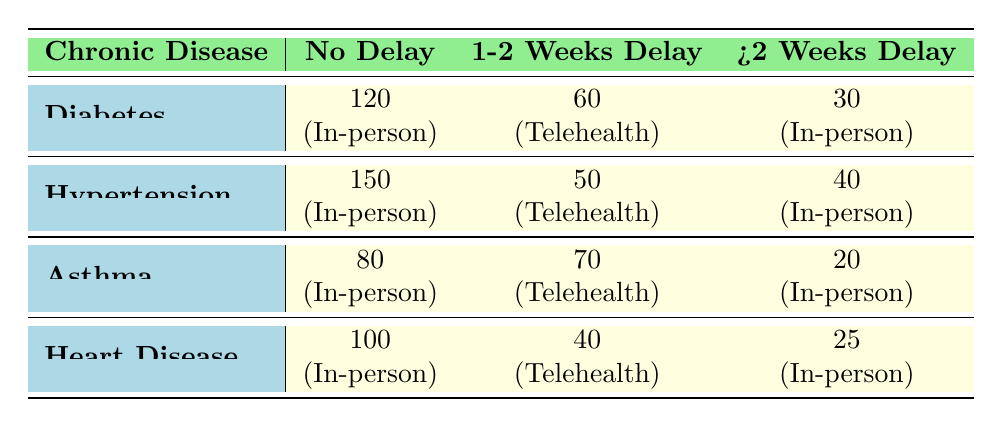What is the patient count for Diabetes with no service delay? The row for Diabetes states that the patient count with no service delay is 120 based on the data in the table.
Answer: 120 How many patients with Hypertension accessed healthcare via Telehealth with a service delay of 1-2 weeks? The table indicates that the patient count for Hypertension accessing Telehealth with a 1-2 weeks delay is 50.
Answer: 50 What is the total number of patients for Asthma experiencing any service delay? By adding the patient counts for Asthma with delays: 70 (1-2 weeks) + 20 (>2 weeks) = 90. Therefore, the total number of patients experiencing delays is 90.
Answer: 90 Is there a higher patient count for Heart Disease with no delay compared to patient count for Asthma with a 1-2 weeks delay? The patient count for Heart Disease with no delay is 100, while for Asthma with a 1-2 weeks delay it is 70. Since 100 > 70, the comparison is true.
Answer: Yes What is the average patient count for Diabetes across all service delay categories? The patient counts for Diabetes are: 120 (no delay) + 60 (1-2 weeks) + 30 (>2 weeks) = 210. There are 3 categories, so 210 / 3 = 70.
Answer: 70 